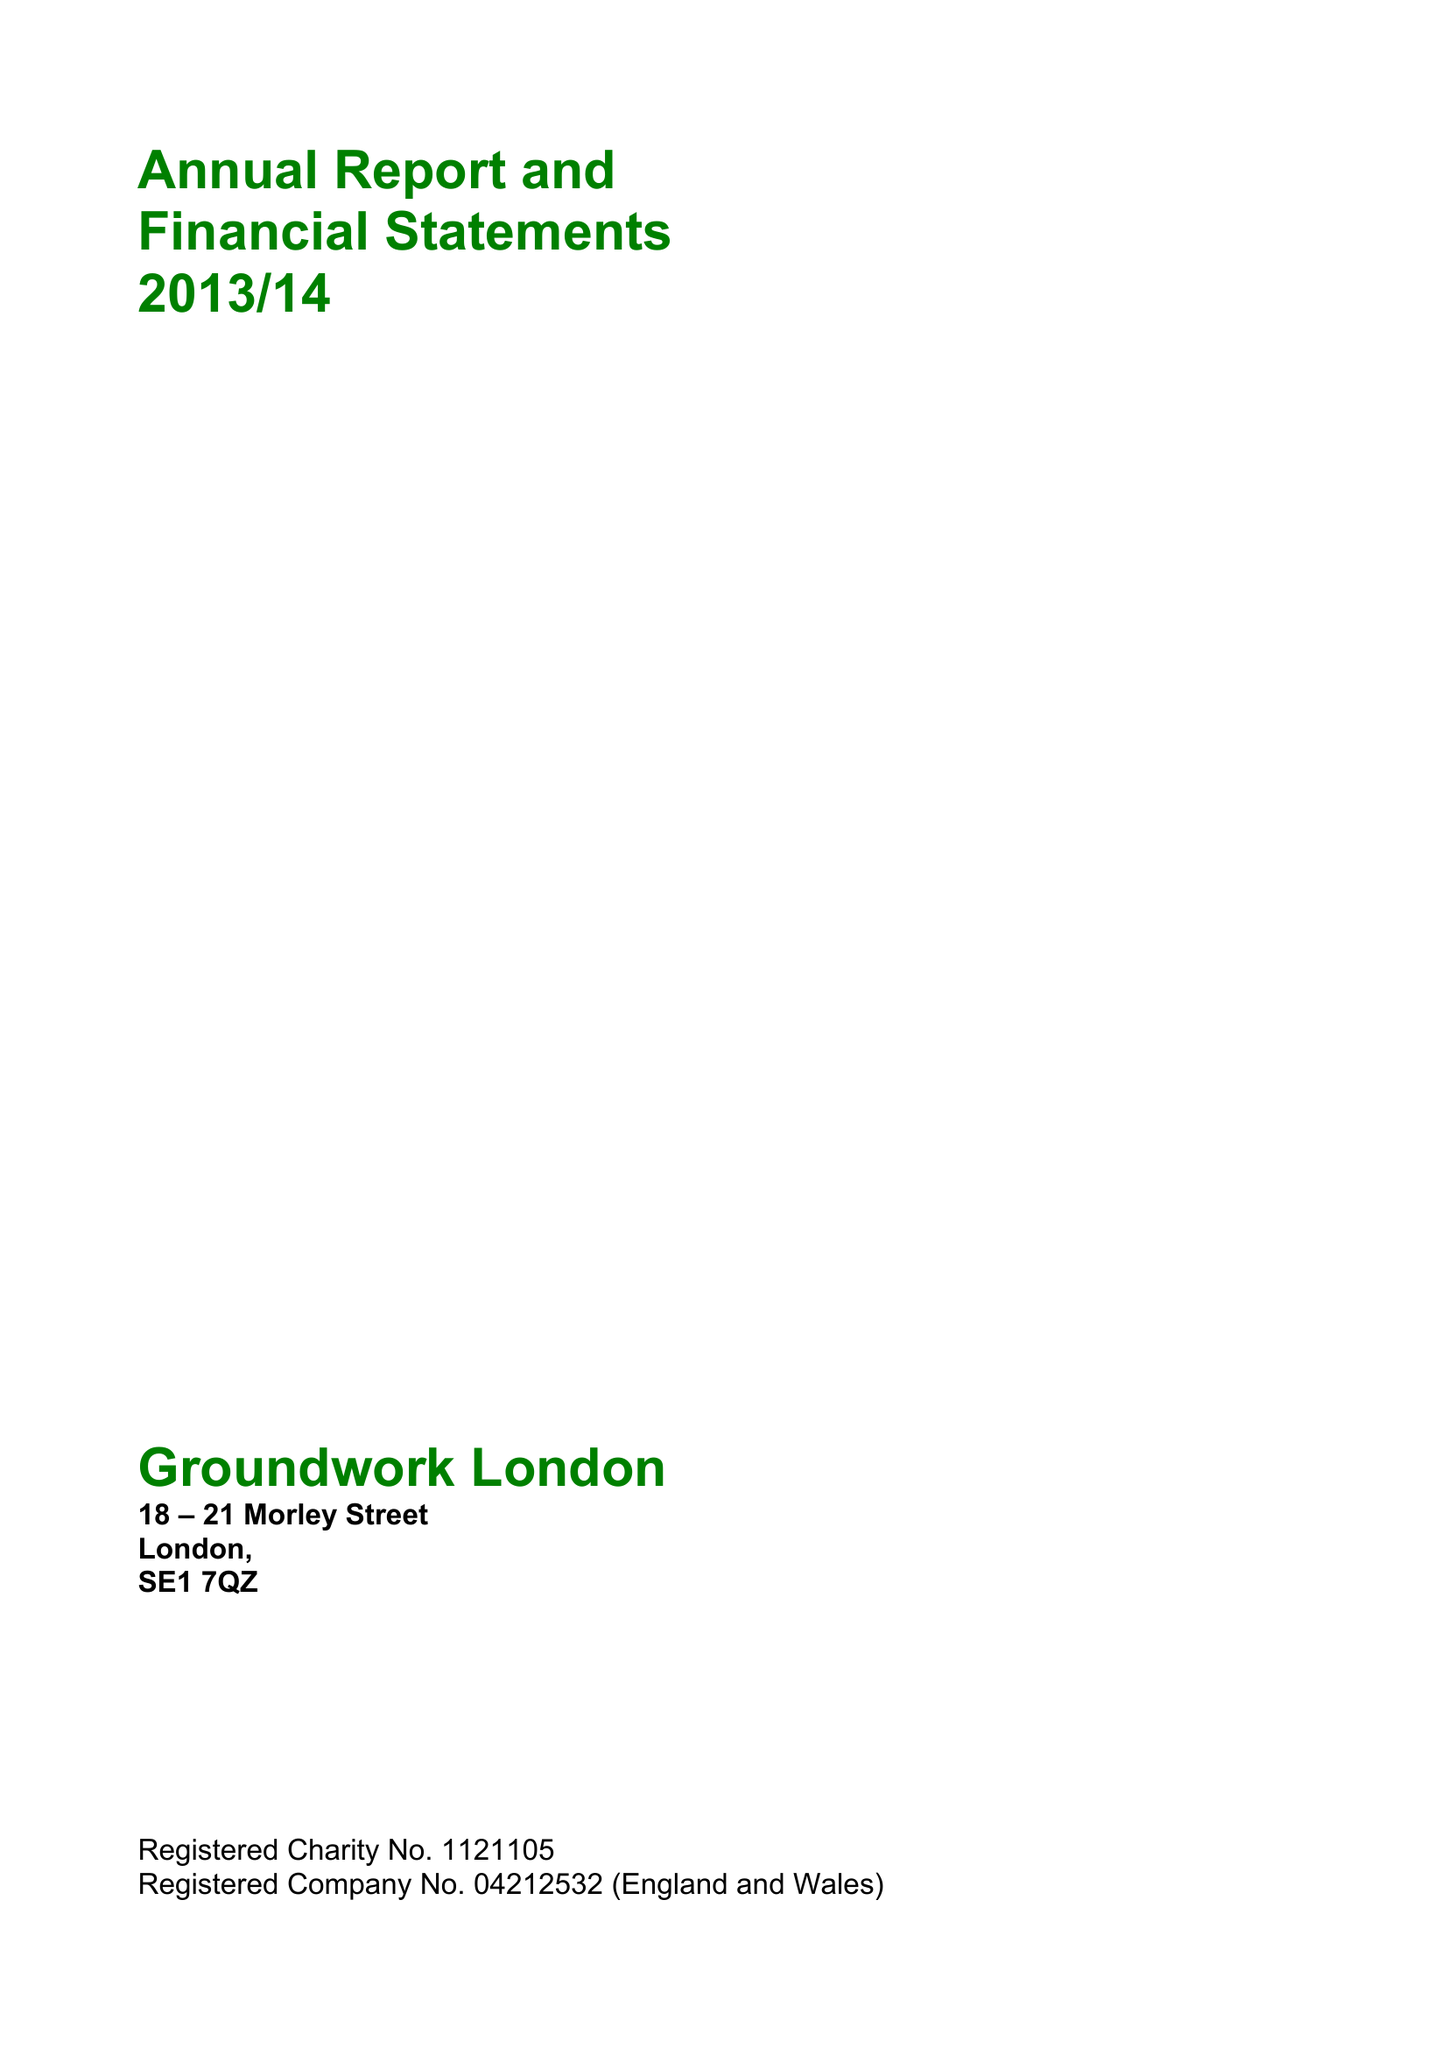What is the value for the spending_annually_in_british_pounds?
Answer the question using a single word or phrase. 9936360.00 